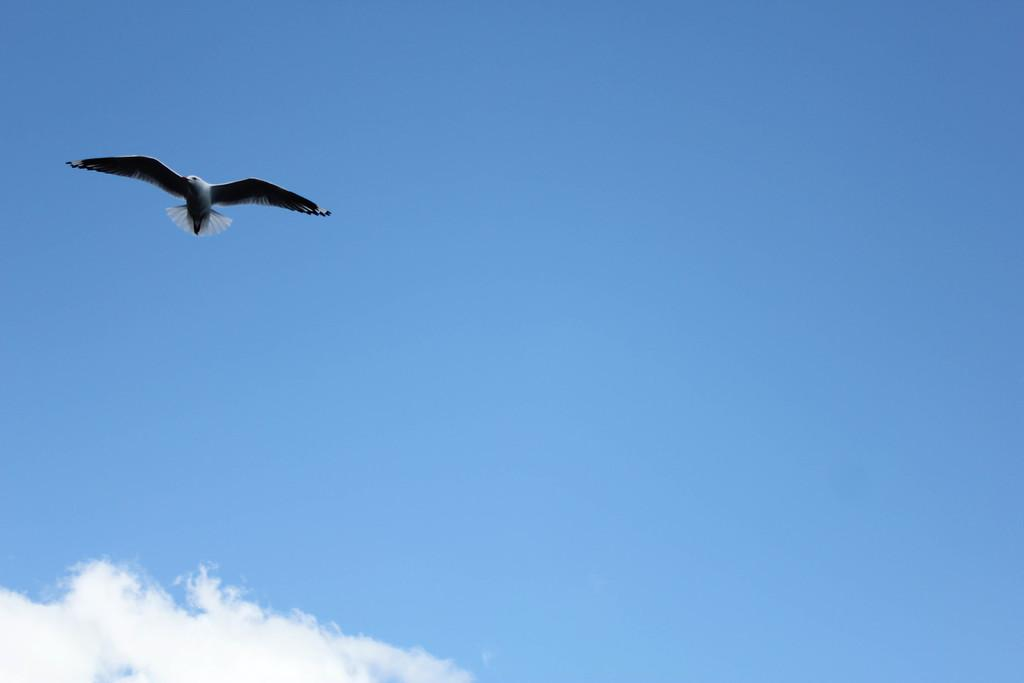What is the main subject of the image? There is a bird flying in the air. What can be seen in the background of the image? The sky is visible in the background of the image. What is the condition of the sky in the image? There are clouds in the sky. What type of yarn is the bird using to fly in the image? There is no yarn present in the image, and birds do not use yarn to fly. 